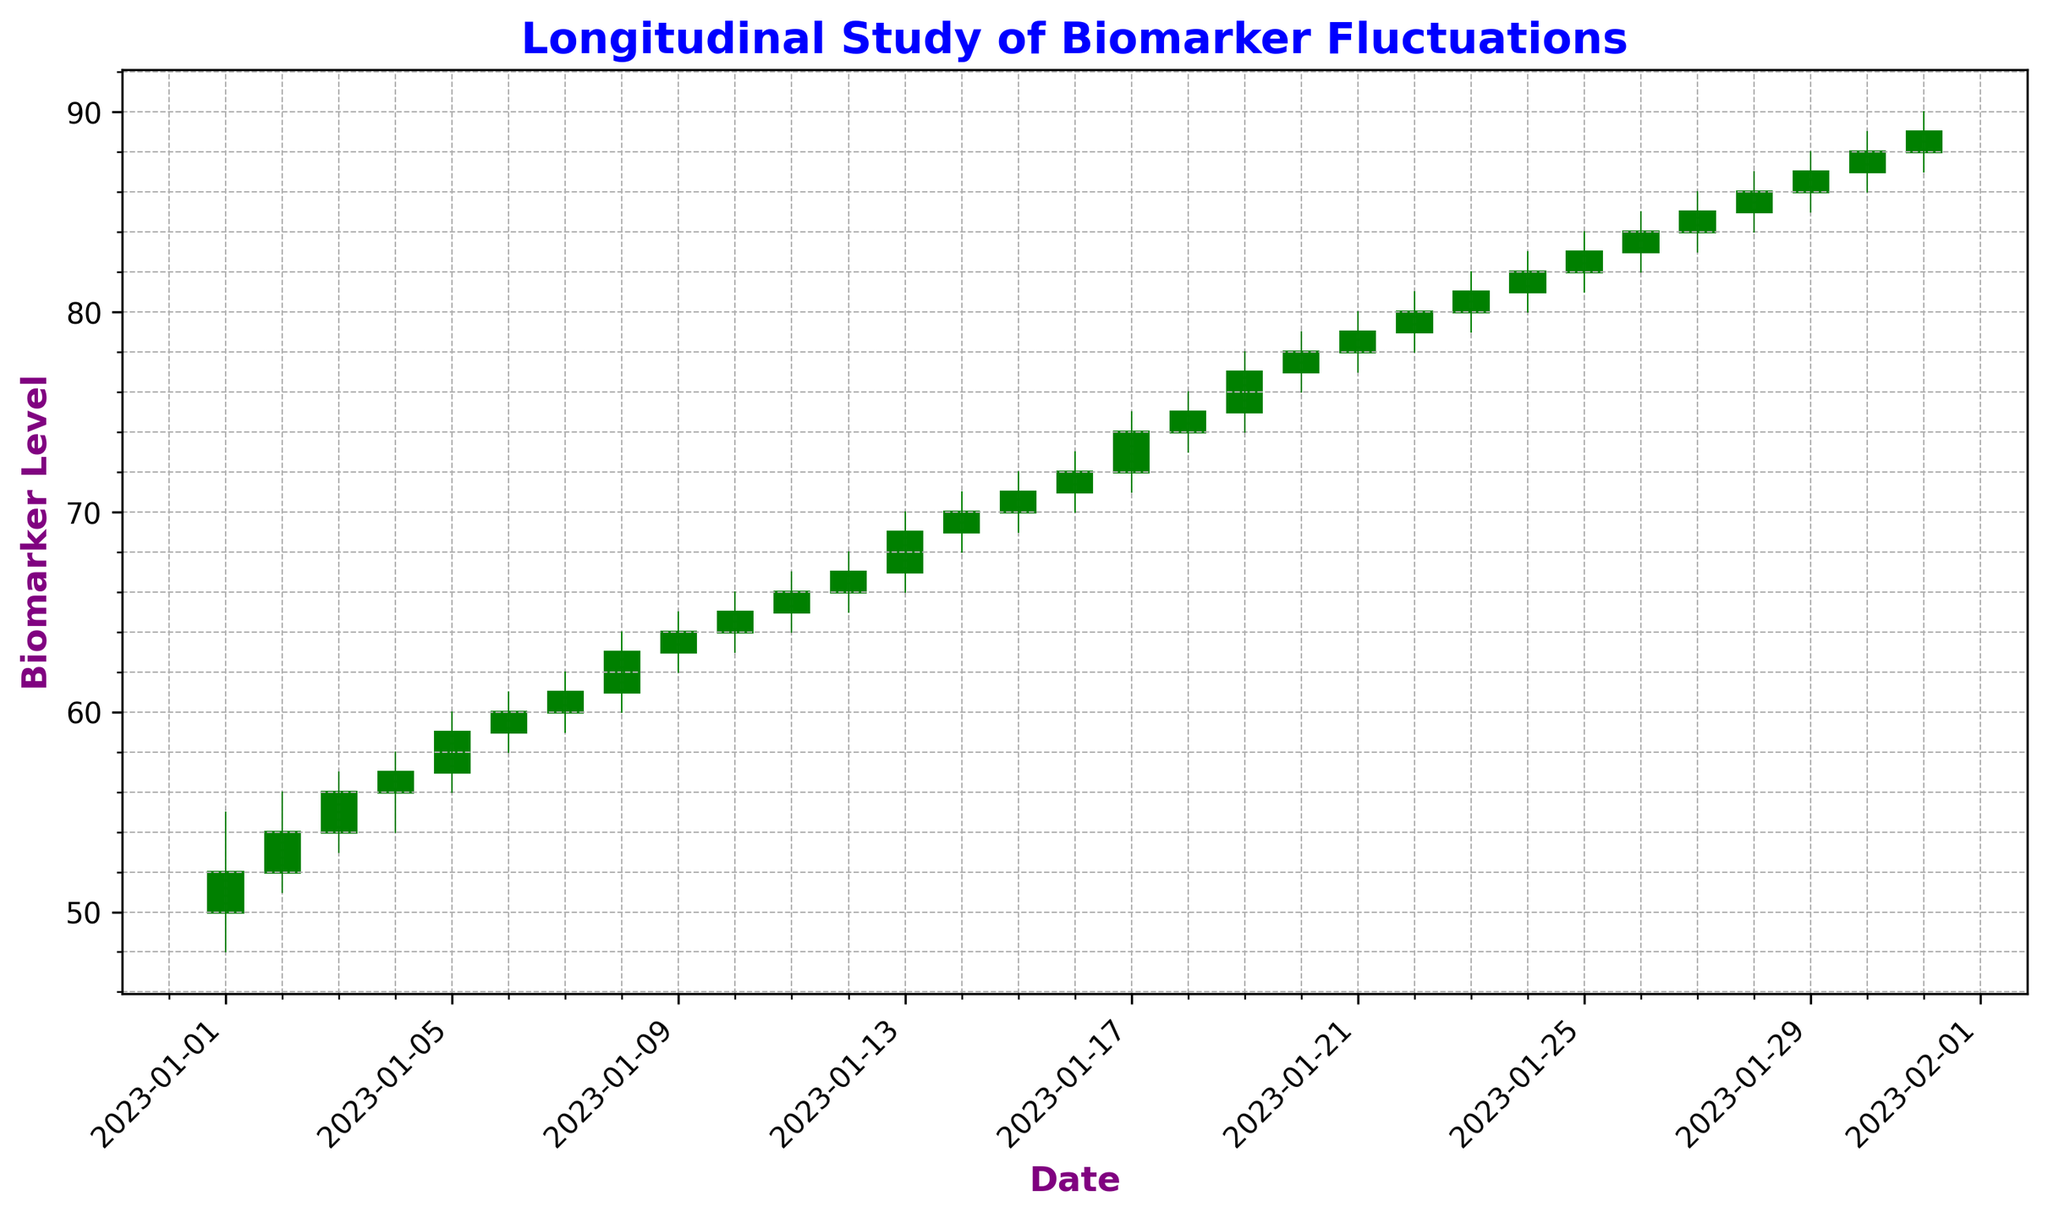Which date shows the highest closing value within the time span? To determine the highest closing value, look at the 'Close' values and identify the highest number. In this case, 89 is the highest, which occurs on 2023-01-31.
Answer: 2023-01-31 On which date did the biomarker open at the highest value? To find the date with the highest opening value, examine the 'Open' values and locate the highest number. Here, 88 is the highest opening value, which occurs on 2023-01-31.
Answer: 2023-01-31 What was the average closing value in the first week (January 1 to January 7)? Average the closing values from January 1 to January 7. Closing values are: 52, 54, 56, 57, 59, 60, and 61. Calculate the average: (52 + 54 + 56 + 57 + 59 + 60 + 61) / 7 = 56.43.
Answer: 56.43 Which day had the greatest difference between the high and low values? Calculate the difference between 'High' and 'Low' for each date and identify the maximum. January 13 has the greatest difference of 4 (70 - 66).
Answer: January 13 Is there any day with a lower closing value than its opening value? Review each date to see if the 'Close' value is less than the 'Open' value. There are none; all closing values are equal to or higher than their opening values.
Answer: No What was the increase in the closing value from January 1 to January 31? Subtract the closing value on January 1 (52) from the closing value on January 31 (89). The increase is 89 - 52 = 37.
Answer: 37 Did the volume trend generally increase, decrease, or stay constant over the period? Observe the overall trend of 'Volume' values over the time period. Volume shows an increasing trend from 1500 on January 1 to 4500 on January 31.
Answer: Increase Which week had the highest average volume? Divide the period into weeks and calculate the average volume for each week. Week 4 (January 22-28) has the highest average volume:
(3600 + 3700 + 3800 + 3900 + 4000 + 4100 + 4200)/7 = 3900.
Answer: Week 4 (January 22-28) Between January 1 and January 15, which date had the largest single-day gain in closing value? Calculate the difference in closing values between consecutive days during January 1 to January 15. January 13 has the largest gain: 70 - 67 = 3.
Answer: January 13 On which date was the closing value exactly equal to the opening value? Review the data to find where 'Close' equals 'Open'. January 5 (57 = 57) and January 22 (80 = 80) meet this condition.
Answer: January 5 and January 22 